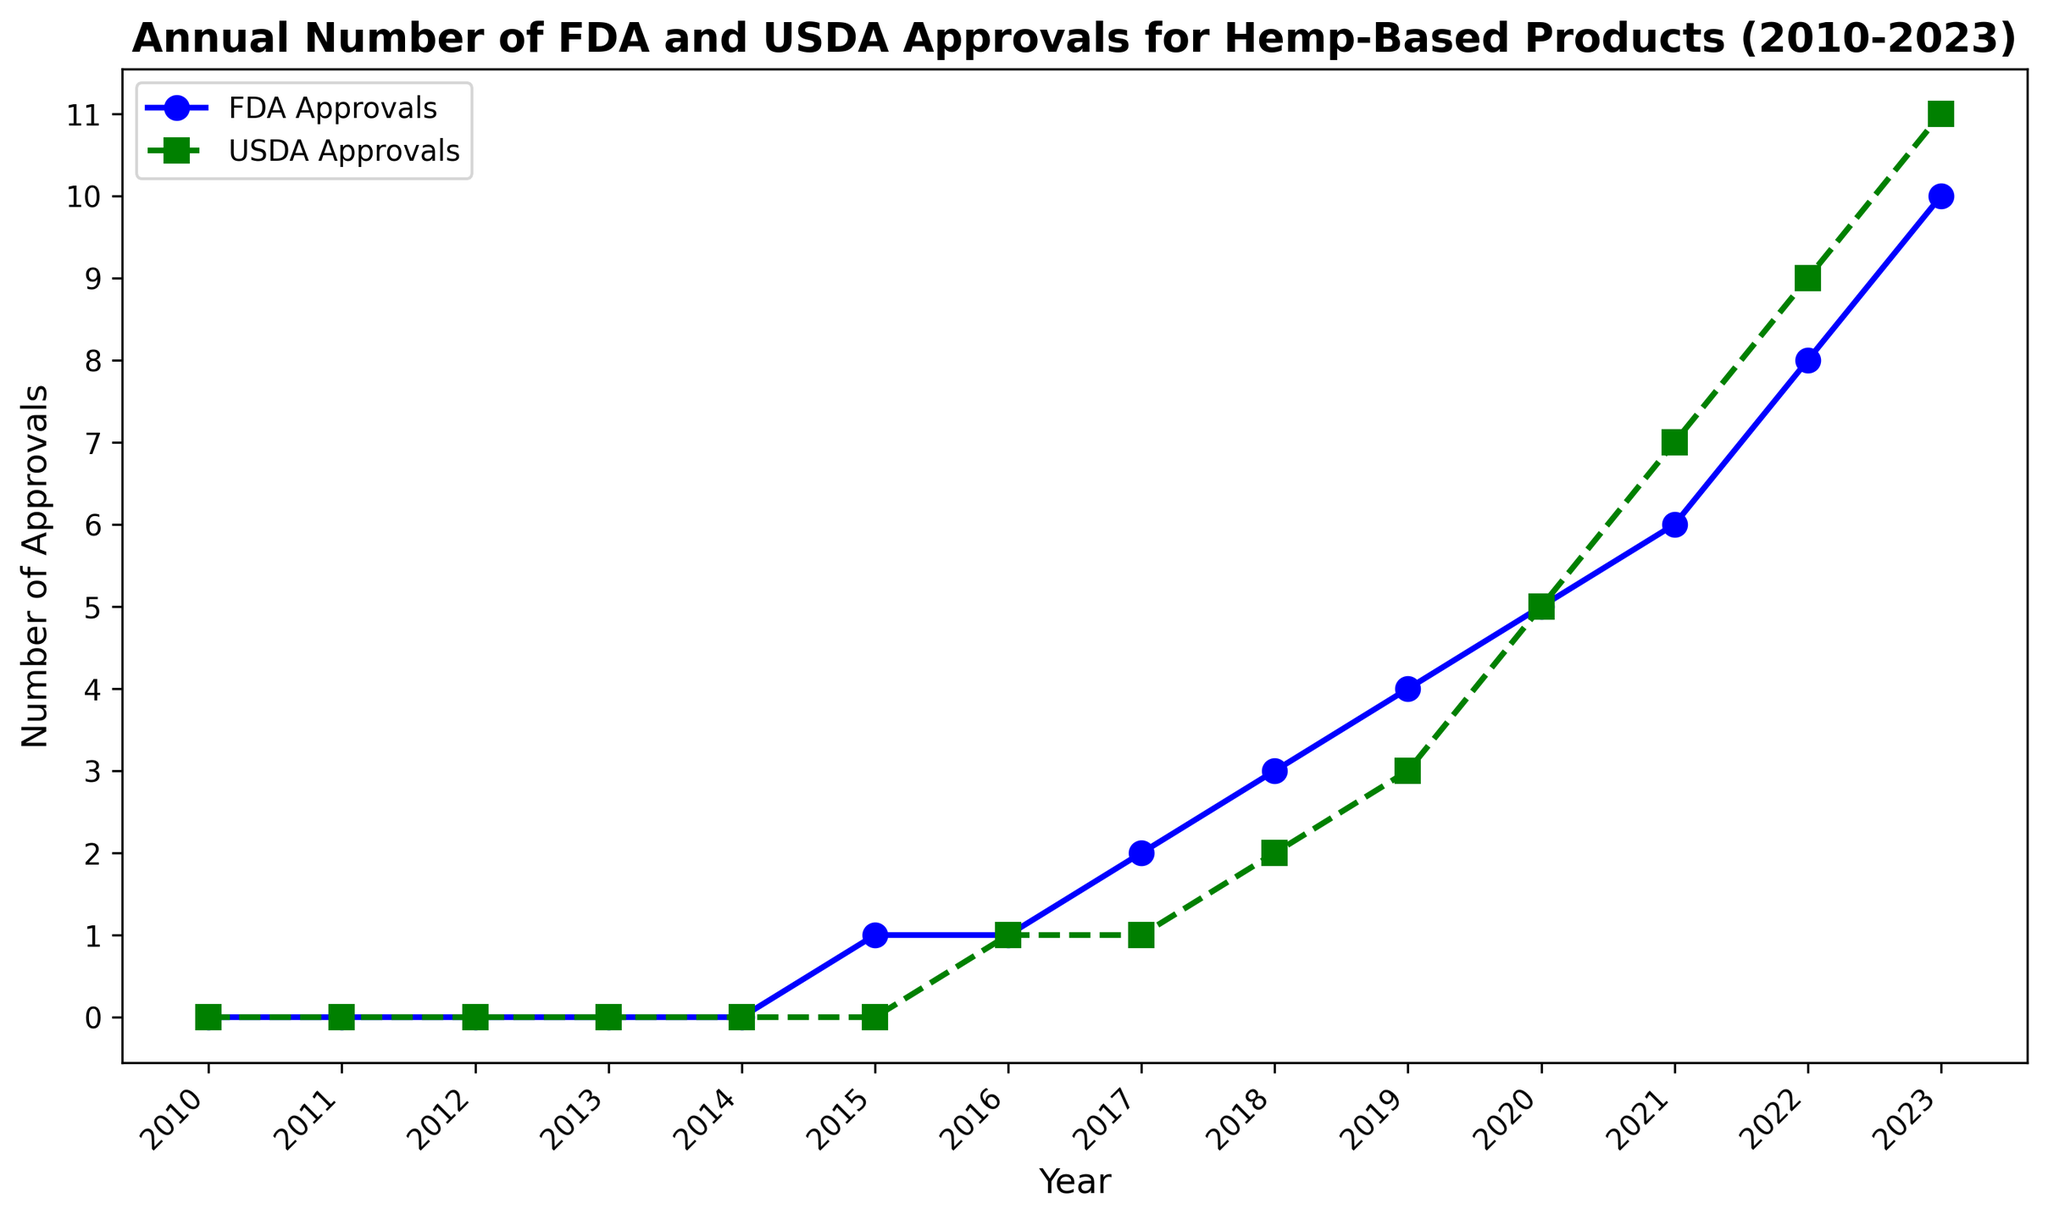What's the difference in the number of FDA and USDA approvals in 2019? In 2019, FDA approvals were 4 and USDA approvals were 3. The difference is found by subtracting the USDA approvals from the FDA approvals: 4 - 3 = 1.
Answer: 1 Which year marked the first instance where both FDA and USDA had at least one approval? The first year in which both FDA and USDA had at least one approval is 2016, as both have one approval in that year according to the chart.
Answer: 2016 What is the average number of USDA approvals between 2020 and 2023? The number of USDA approvals from 2020 to 2023 are 5, 7, 9, and 11. Sum these values: 5 + 7 + 9 + 11 = 32. Divide by the number of data points, which is 4: 32 / 4 = 8.
Answer: 8 In which year was the growth in the number of FDA approvals the largest compared to the previous year? The biggest growth in FDA approvals compared to the previous year happened between 2021 and 2022, where approvals increased from 6 to 8. This is a growth of 2 approvals.
Answer: 2022 Are there any years where the number of FDA and USDA approvals were the same? If so, which year(s)? Yes, in 2020, the number of FDA and USDA approvals were both 5.
Answer: 2020 How many more approvals did the USDA have compared to the FDA in 2023? In 2023, USDA had 11 approvals and FDA had 10 approvals. The difference is 11 - 10 = 1.
Answer: 1 What is the trend in FDA approvals from 2010 to 2023? The trend in FDA approvals from 2010 to 2023 is an upward trend, starting from 0 approvals in 2010 to 10 approvals in 2023, with incremental increases almost every year.
Answer: Upward In which year did USDA approvals surpass FDA approvals for the first time? USDA approvals surpassed FDA approvals for the first time in 2021, with 7 USDA approvals compared to 6 FDA approvals.
Answer: 2021 What is the cumulative number of FDA and USDA approvals by 2020? By 2020, FDA approvals are 1+1+2+3+4+5 = 16 and USDA approvals are 1+2+3+5 = 11. Their cumulative sum is 16 + 11 = 27.
Answer: 27 Which agency, FDA or USDA, showed a more rapid increase in approvals from 2018 to 2020? For FDA: 2018 (3), 2019 (4), 2020 (5); the increase is 5-3 = 2. For USDA: 2018 (2), 2019 (3), 2020 (5); the increase is 5-2 = 3. USDA had a more rapid increase in approvals.
Answer: USDA 